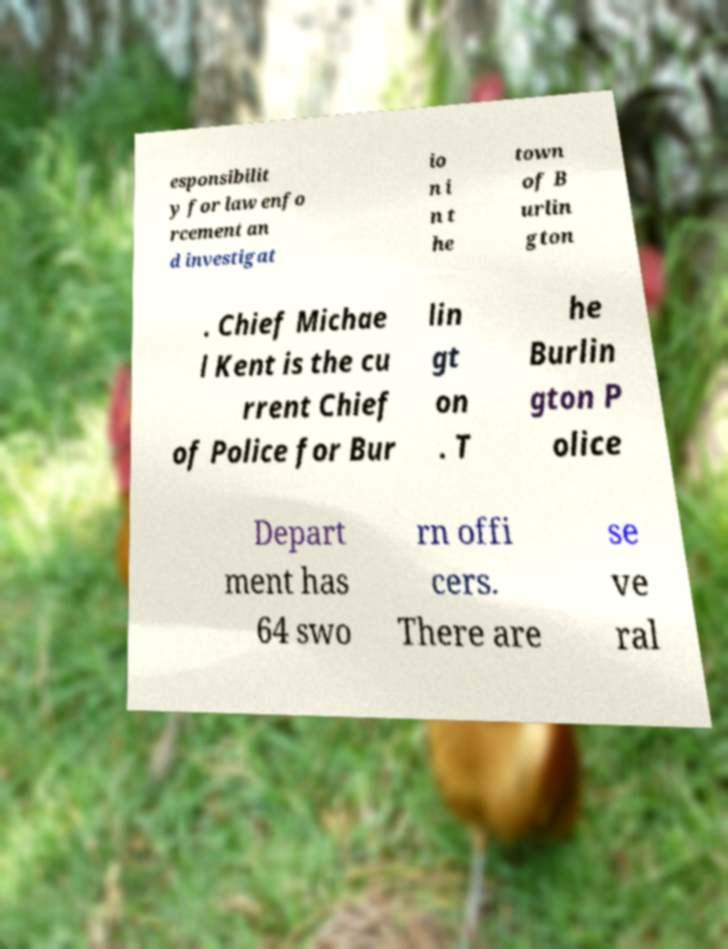For documentation purposes, I need the text within this image transcribed. Could you provide that? esponsibilit y for law enfo rcement an d investigat io n i n t he town of B urlin gton . Chief Michae l Kent is the cu rrent Chief of Police for Bur lin gt on . T he Burlin gton P olice Depart ment has 64 swo rn offi cers. There are se ve ral 